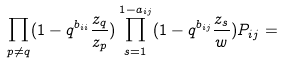Convert formula to latex. <formula><loc_0><loc_0><loc_500><loc_500>\prod _ { p \neq q } ( 1 - q ^ { b _ { i i } } \frac { z _ { q } } { z _ { p } } ) \prod _ { s = 1 } ^ { 1 - a _ { i j } } ( 1 - q ^ { b _ { i j } } \frac { z _ { s } } { w } ) P _ { i j } =</formula> 